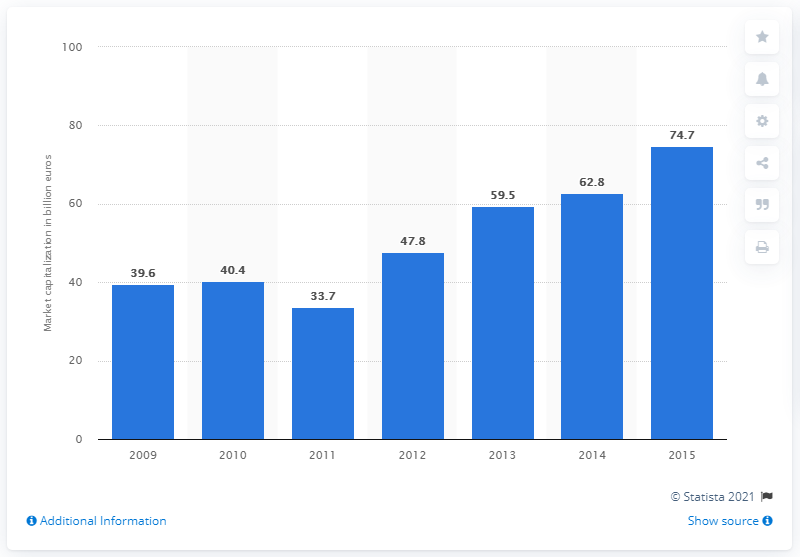Draw attention to some important aspects in this diagram. In 2015, the market capitalization of Allianz Group was 74.7 billion Euros. In 2009, the market capitalization of the Allianz Group was 39.6 billion dollars. 